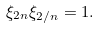Convert formula to latex. <formula><loc_0><loc_0><loc_500><loc_500>\xi _ { 2 n } \xi _ { 2 / n } = 1 .</formula> 